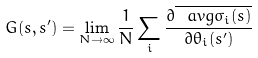Convert formula to latex. <formula><loc_0><loc_0><loc_500><loc_500>G ( s , s ^ { \prime } ) = \lim _ { N \to \infty } \frac { 1 } { N } \sum _ { i } \frac { \partial \overline { \ a v g { \sigma _ { i } ( s ) } } } { \partial \theta _ { i } ( s ^ { \prime } ) }</formula> 